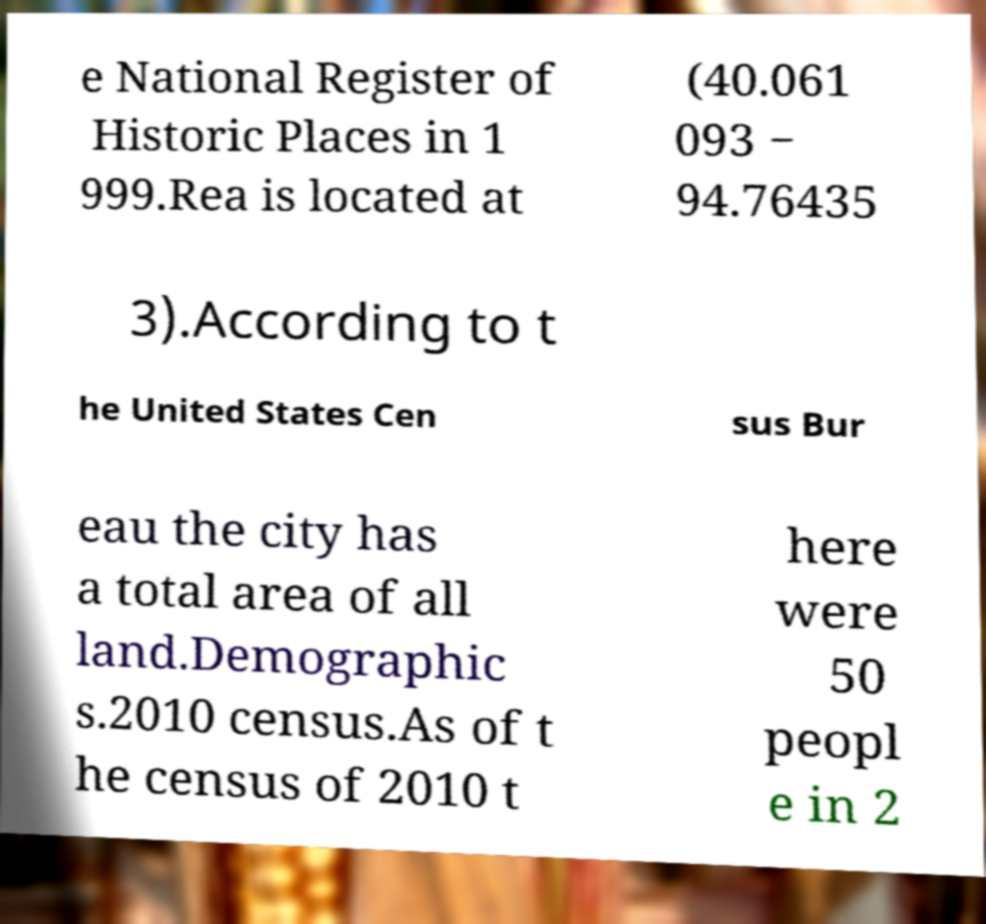What messages or text are displayed in this image? I need them in a readable, typed format. e National Register of Historic Places in 1 999.Rea is located at (40.061 093 − 94.76435 3).According to t he United States Cen sus Bur eau the city has a total area of all land.Demographic s.2010 census.As of t he census of 2010 t here were 50 peopl e in 2 